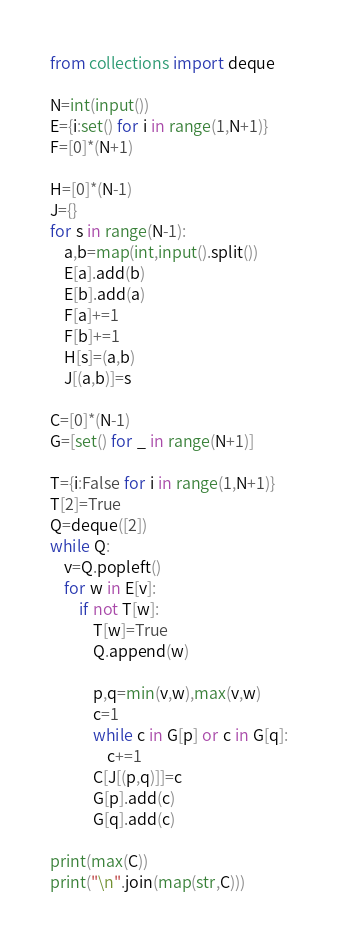Convert code to text. <code><loc_0><loc_0><loc_500><loc_500><_Python_>from collections import deque

N=int(input())
E={i:set() for i in range(1,N+1)}
F=[0]*(N+1)

H=[0]*(N-1)
J={}
for s in range(N-1):
    a,b=map(int,input().split())
    E[a].add(b)
    E[b].add(a)
    F[a]+=1
    F[b]+=1
    H[s]=(a,b)
    J[(a,b)]=s

C=[0]*(N-1)
G=[set() for _ in range(N+1)]

T={i:False for i in range(1,N+1)}
T[2]=True
Q=deque([2])
while Q:
    v=Q.popleft()
    for w in E[v]:
        if not T[w]:
            T[w]=True
            Q.append(w)

            p,q=min(v,w),max(v,w)
            c=1
            while c in G[p] or c in G[q]:
                c+=1
            C[J[(p,q)]]=c
            G[p].add(c)
            G[q].add(c)

print(max(C))
print("\n".join(map(str,C)))

</code> 